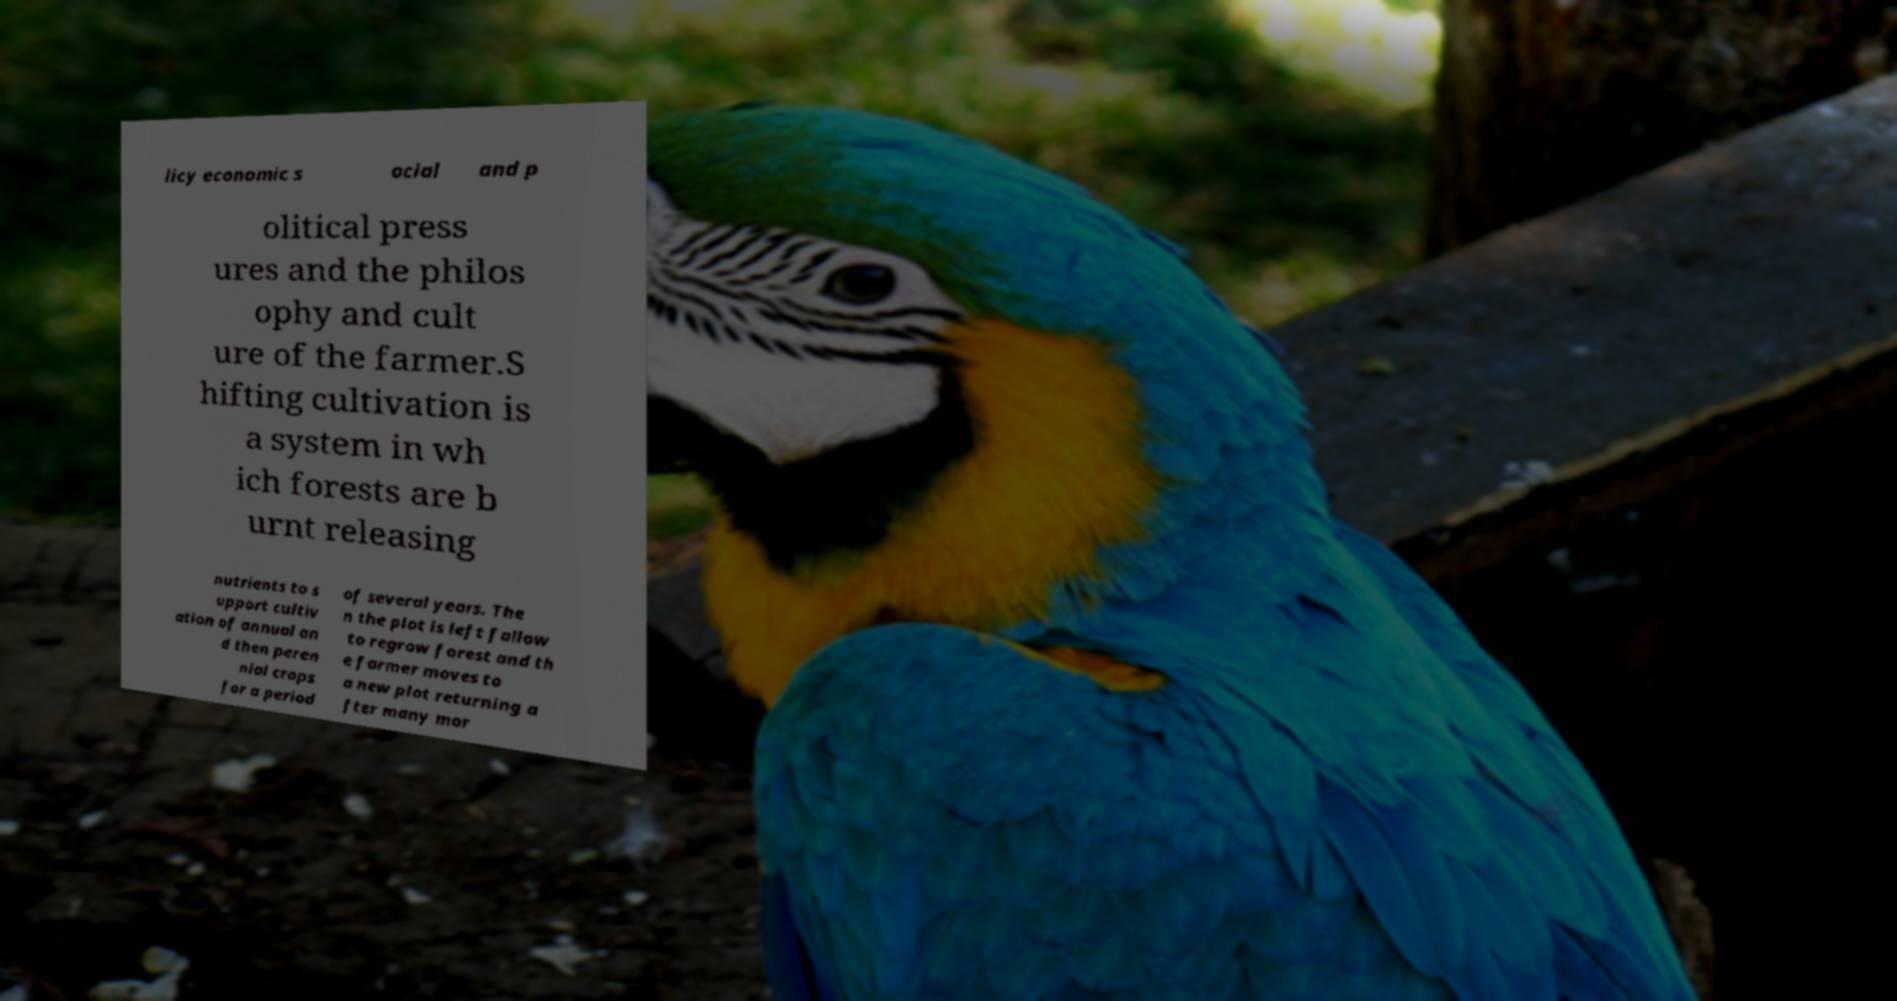I need the written content from this picture converted into text. Can you do that? licy economic s ocial and p olitical press ures and the philos ophy and cult ure of the farmer.S hifting cultivation is a system in wh ich forests are b urnt releasing nutrients to s upport cultiv ation of annual an d then peren nial crops for a period of several years. The n the plot is left fallow to regrow forest and th e farmer moves to a new plot returning a fter many mor 